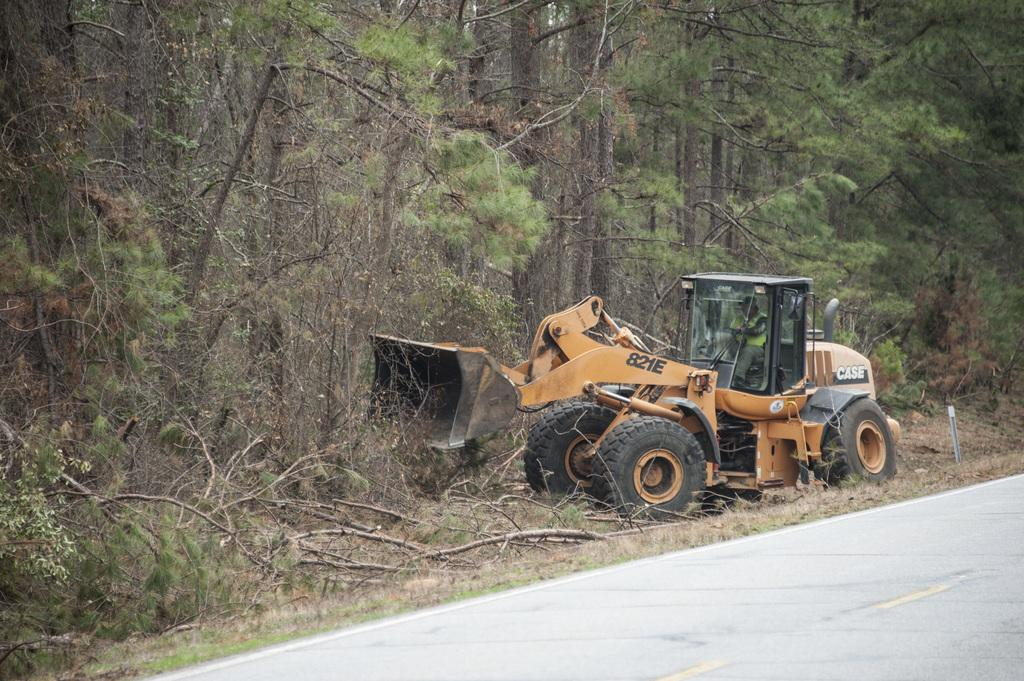<image>
Relay a brief, clear account of the picture shown. A bulldozer with the text 821E is clearing brush. 